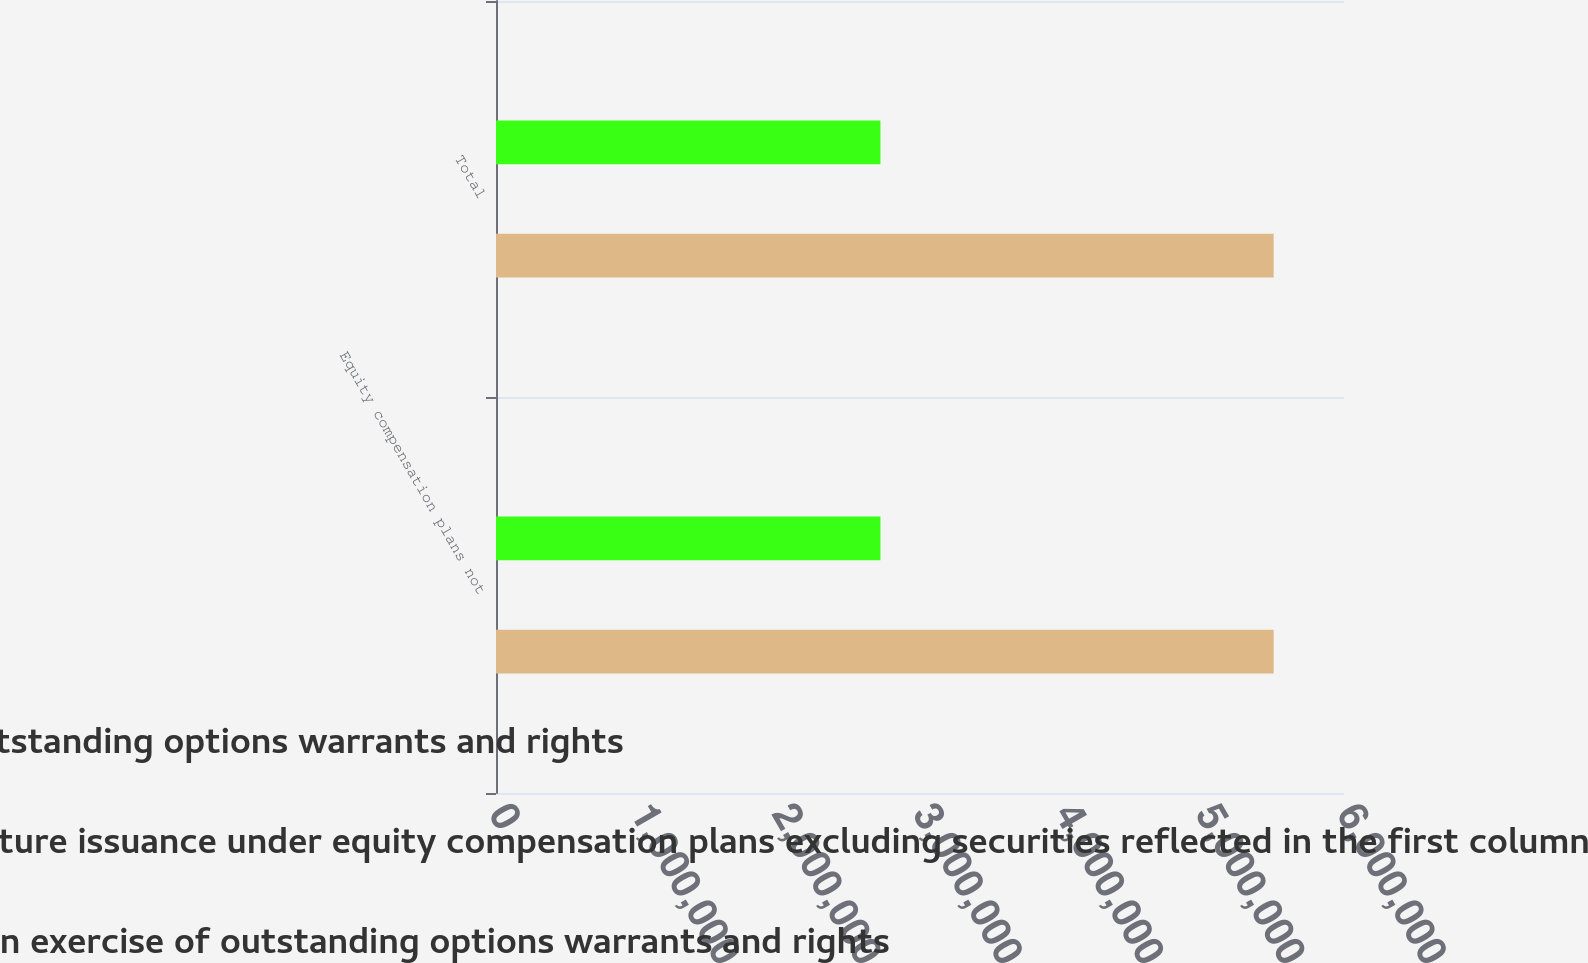<chart> <loc_0><loc_0><loc_500><loc_500><stacked_bar_chart><ecel><fcel>Equity compensation plans not<fcel>Total<nl><fcel>Weightedaverage exercise price of outstanding options warrants and rights<fcel>2.7201e+06<fcel>2.7201e+06<nl><fcel>Number of securities remaining for future issuance under equity compensation plans excluding securities reflected in the first column<fcel>16<fcel>16<nl><fcel>Number of securities to be issued upon exercise of outstanding options warrants and rights<fcel>5.50218e+06<fcel>5.50218e+06<nl></chart> 